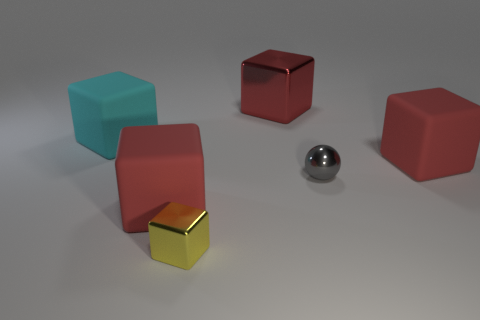How many red cubes must be subtracted to get 1 red cubes? 2 Subtract all red cylinders. How many red cubes are left? 3 Subtract all cyan rubber blocks. How many blocks are left? 4 Subtract all yellow cubes. How many cubes are left? 4 Subtract all purple cubes. Subtract all yellow cylinders. How many cubes are left? 5 Add 4 big red metal cubes. How many objects exist? 10 Subtract all blocks. How many objects are left? 1 Subtract all red blocks. Subtract all yellow metallic blocks. How many objects are left? 2 Add 6 small yellow cubes. How many small yellow cubes are left? 7 Add 1 red metal objects. How many red metal objects exist? 2 